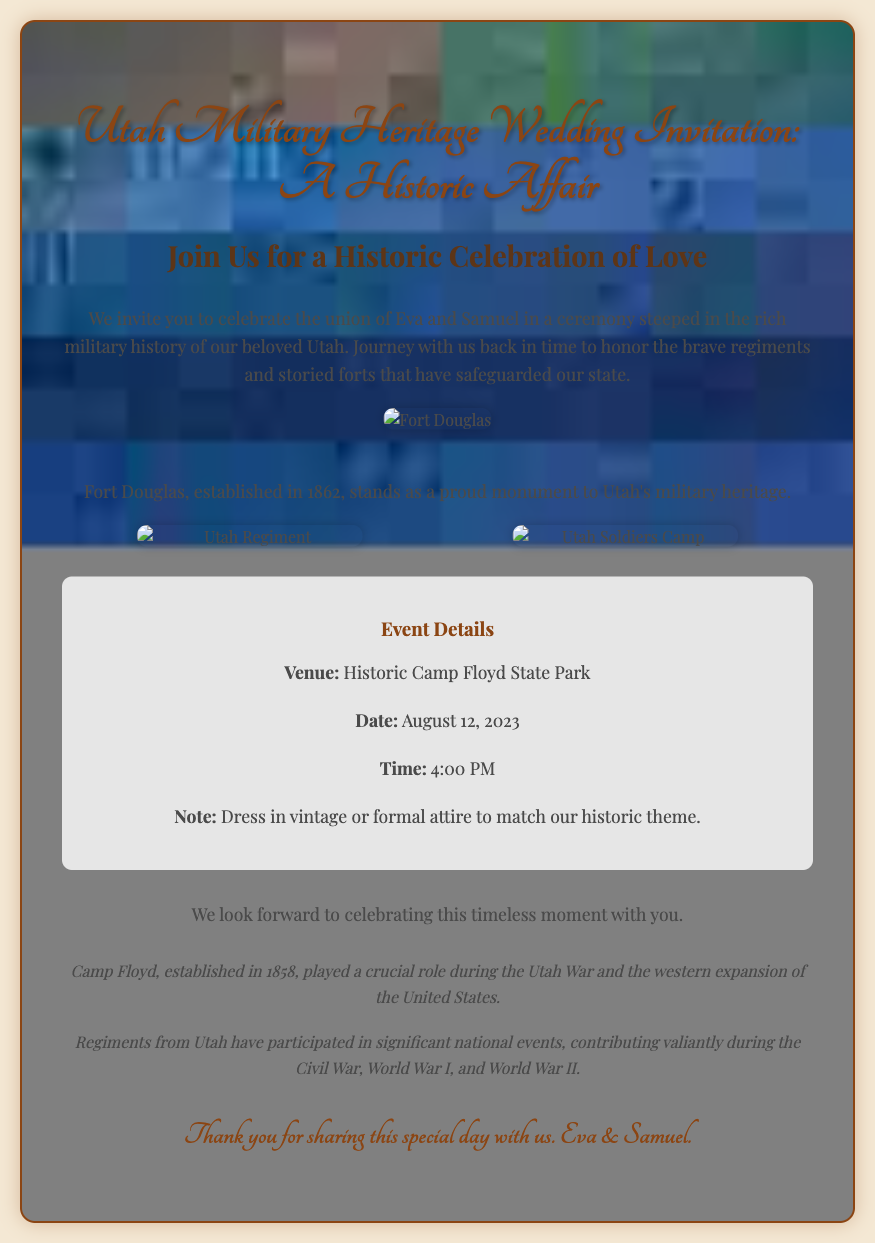What are the names of the couple? The couple's names are mentioned in the invitation text, which states "the union of Eva and Samuel."
Answer: Eva and Samuel What is the venue for the wedding? The venue is explicitly stated in the details section of the invitation as "Historic Camp Floyd State Park."
Answer: Historic Camp Floyd State Park What is the date of the wedding? The wedding date is clearly listed in the event details section, which specifies "August 12, 2023."
Answer: August 12, 2023 At what time will the ceremony take place? The time of the ceremony is mentioned in the invitation under event details, stated as "4:00 PM."
Answer: 4:00 PM What special attire is requested for guests? The invitation includes a note about attire, requesting "vintage or formal attire to match our historic theme."
Answer: Vintage or formal attire What historic event is associated with Camp Floyd? The invitation notes that Camp Floyd "played a crucial role during the Utah War and the western expansion of the United States."
Answer: Utah War How does the wedding theme relate to Utah's military history? The theme is tied to Utah's military heritage, focusing on "the brave regiments and storied forts that have safeguarded our state."
Answer: Military heritage What style of images is featured on the invitation? The invitation utilizes "sepia-toned images" that reflect the historic theme.
Answer: Sepia-toned images What type of celebration is the invitation promoting? The invitation states it is promoting "a historic celebration of love."
Answer: Historic celebration of love 